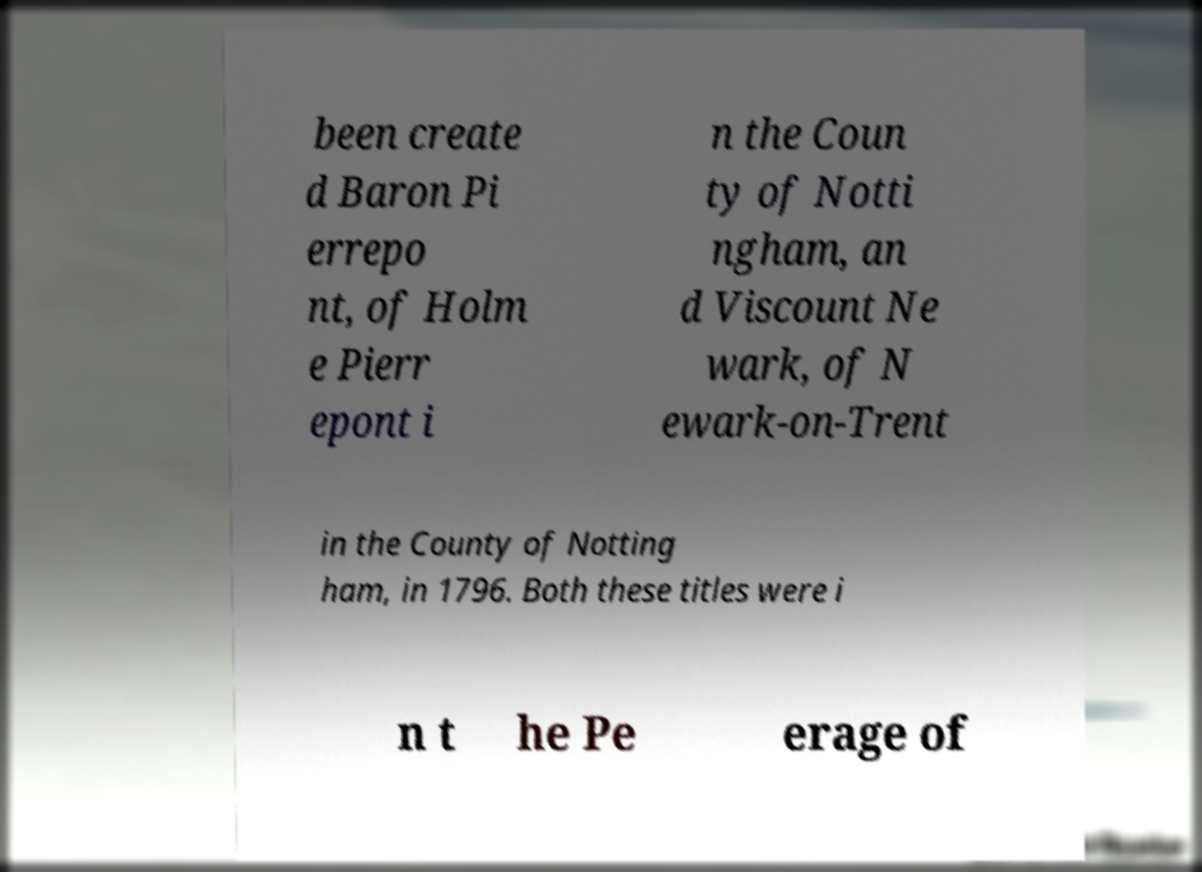There's text embedded in this image that I need extracted. Can you transcribe it verbatim? been create d Baron Pi errepo nt, of Holm e Pierr epont i n the Coun ty of Notti ngham, an d Viscount Ne wark, of N ewark-on-Trent in the County of Notting ham, in 1796. Both these titles were i n t he Pe erage of 